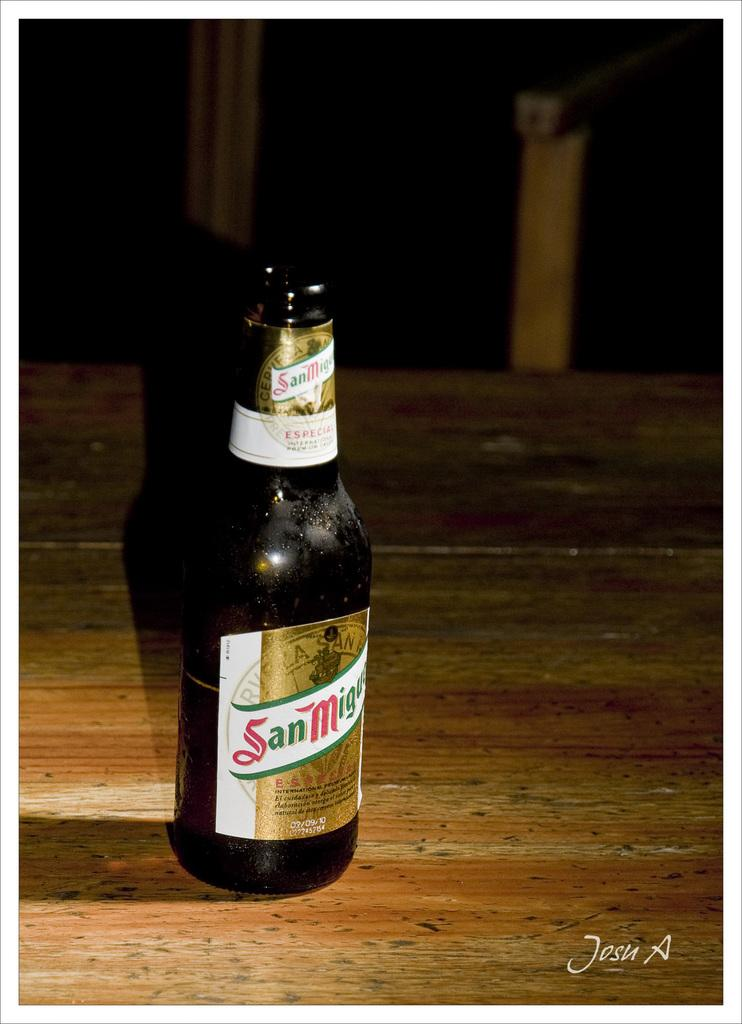<image>
Present a compact description of the photo's key features. A bottle of San Miguel beer sits on a wooden table. 